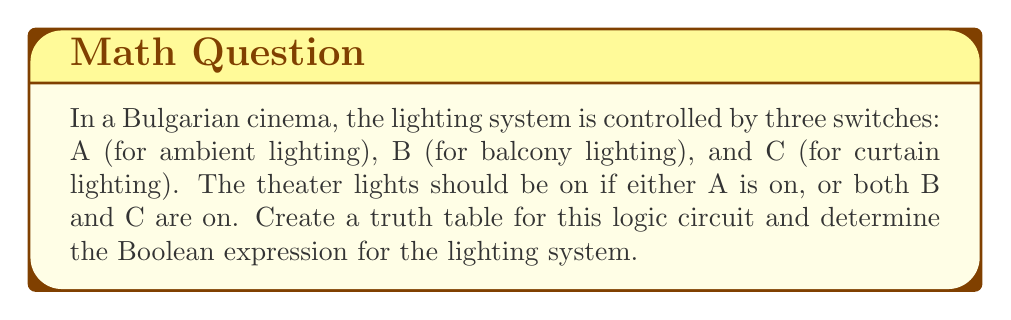Could you help me with this problem? Let's approach this step-by-step:

1) First, we need to identify our inputs and output:
   Inputs: A, B, C
   Output: L (Lighting)

2) Now, let's create the truth table with all possible combinations of inputs:

   | A | B | C | L |
   |---|---|---|---|
   | 0 | 0 | 0 | 0 |
   | 0 | 0 | 1 | 0 |
   | 0 | 1 | 0 | 0 |
   | 0 | 1 | 1 | 1 |
   | 1 | 0 | 0 | 1 |
   | 1 | 0 | 1 | 1 |
   | 1 | 1 | 0 | 1 |
   | 1 | 1 | 1 | 1 |

3) From the problem statement, we can derive the logic:
   - Lights are on if A is on: This is represented by A
   - Lights are on if both B and C are on: This is represented by B AND C

4) Combining these conditions with OR, we get the Boolean expression:

   $$ L = A + (B \cdot C) $$

   Where '+' represents OR, and '·' represents AND.

5) We can verify this expression with our truth table:
   - When A is 1, L is always 1
   - When A is 0, L is 1 only when both B and C are 1

This Boolean expression accurately represents the lighting control system for our Bulgarian cinema.
Answer: $$ L = A + (B \cdot C) $$ 